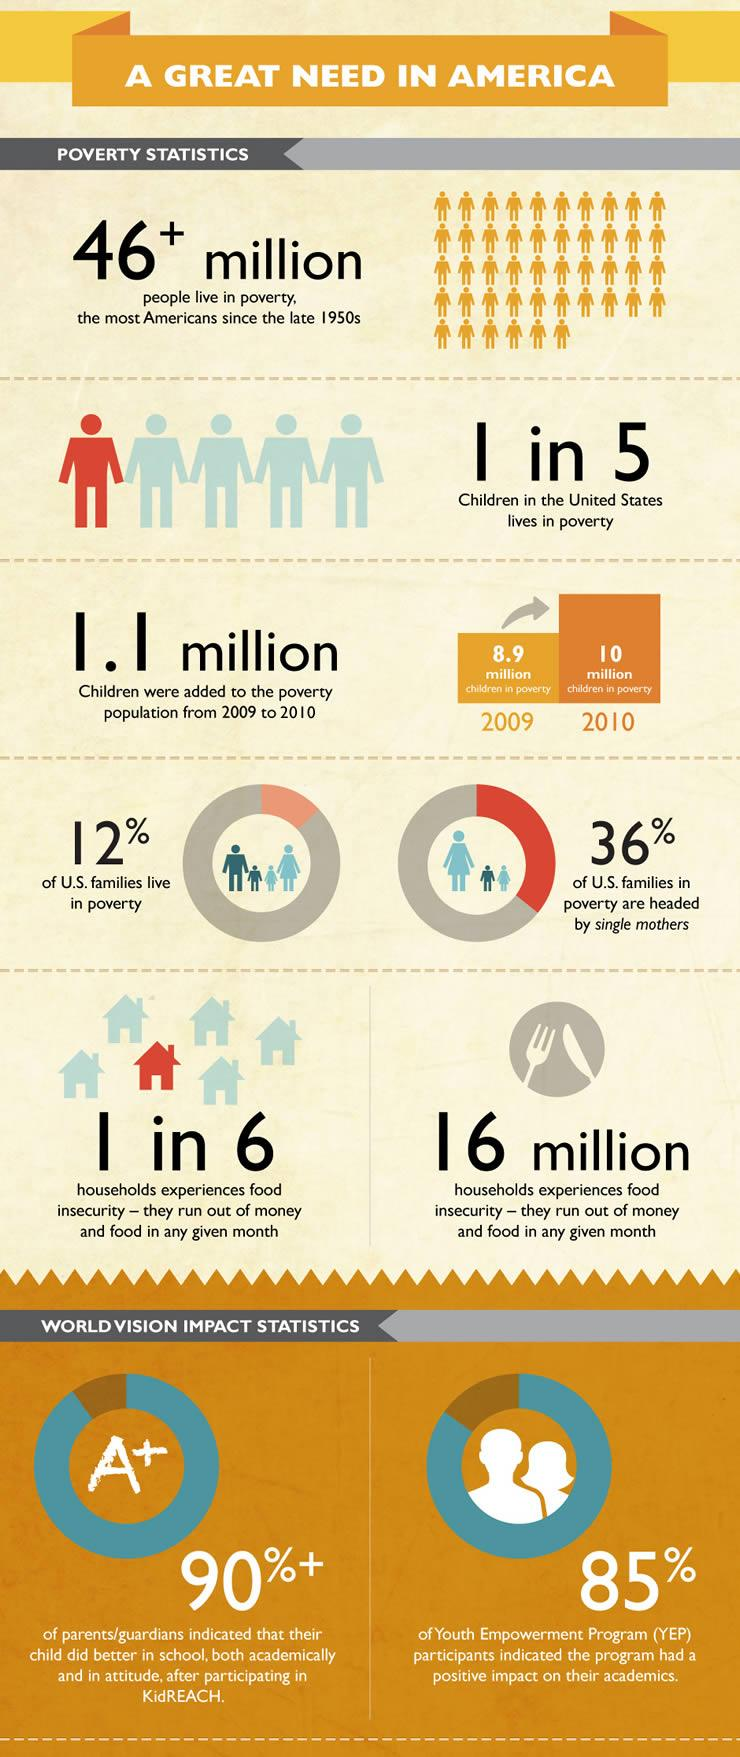Draw attention to some important aspects in this diagram. In the United States, approximately 12% of families live in poverty. According to recent data, approximately 36% of U.S. families living in poverty are headed by single mothers. 